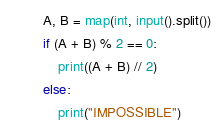<code> <loc_0><loc_0><loc_500><loc_500><_Python_>A, B = map(int, input().split())
if (A + B) % 2 == 0:
    print((A + B) // 2)
else:
    print("IMPOSSIBLE")</code> 